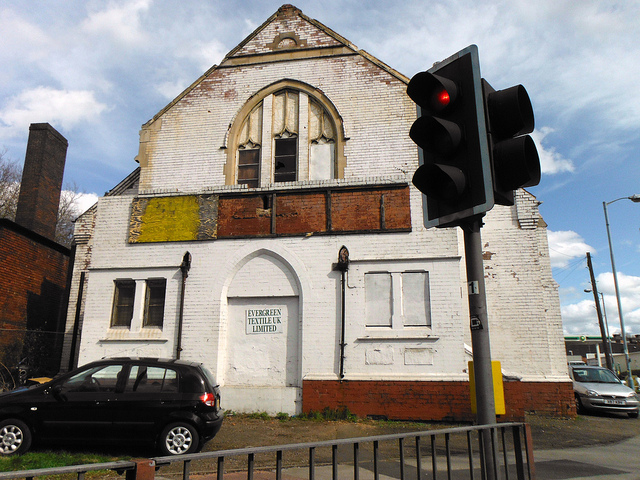<image>What style of architecture does the building exemplify? I am not sure what style of architecture the building exemplifies. It could be gothic, industrial or early Spanish. What style of architecture does the building exemplify? It is ambiguous what style of architecture the building exemplifies. It can be seen as 'old', 'gothic', 'church', 'industrial', 'ancient', 'religious', or 'early spanish'. 